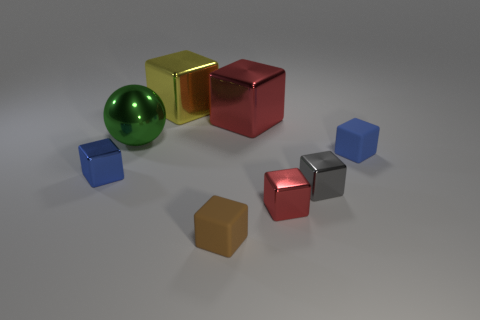Is the number of small things that are behind the blue rubber block the same as the number of tiny red blocks?
Give a very brief answer. No. What number of red objects have the same size as the green shiny ball?
Provide a succinct answer. 1. Are any brown cubes visible?
Keep it short and to the point. Yes. Is the shape of the tiny matte object right of the brown matte thing the same as the large thing that is in front of the big red metallic cube?
Offer a terse response. No. How many small things are either blue metallic objects or cyan matte balls?
Your response must be concise. 1. The large yellow thing that is the same material as the small red cube is what shape?
Keep it short and to the point. Cube. Does the brown object have the same shape as the gray thing?
Offer a very short reply. Yes. What color is the big sphere?
Ensure brevity in your answer.  Green. How many things are either big gray objects or gray cubes?
Ensure brevity in your answer.  1. Is there anything else that is the same material as the large red block?
Offer a terse response. Yes. 